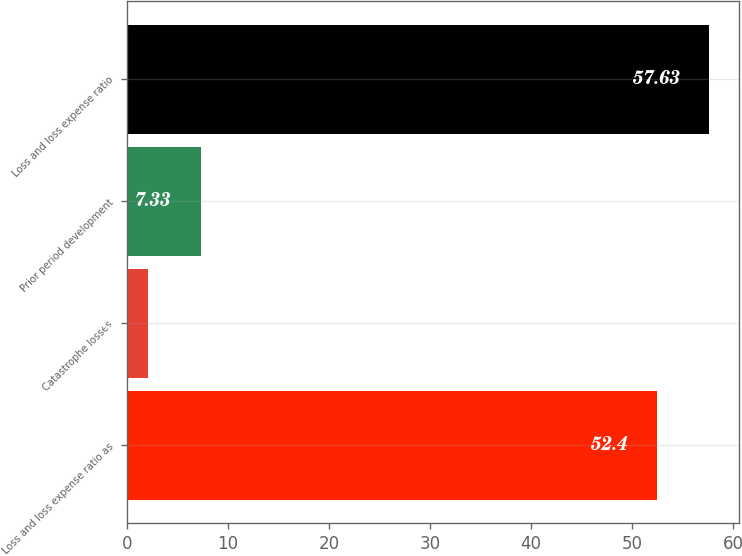<chart> <loc_0><loc_0><loc_500><loc_500><bar_chart><fcel>Loss and loss expense ratio as<fcel>Catastrophe losses<fcel>Prior period development<fcel>Loss and loss expense ratio<nl><fcel>52.4<fcel>2.1<fcel>7.33<fcel>57.63<nl></chart> 